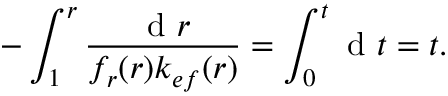Convert formula to latex. <formula><loc_0><loc_0><loc_500><loc_500>- \int _ { 1 } ^ { r } \frac { d r } { f _ { r } ( r ) k _ { e f } ( r ) } = \int _ { 0 } ^ { t } d t = t .</formula> 